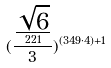Convert formula to latex. <formula><loc_0><loc_0><loc_500><loc_500>( \frac { \frac { \sqrt { 6 } } { 2 2 1 } } { 3 } ) ^ { ( 3 4 9 \cdot 4 ) + 1 }</formula> 